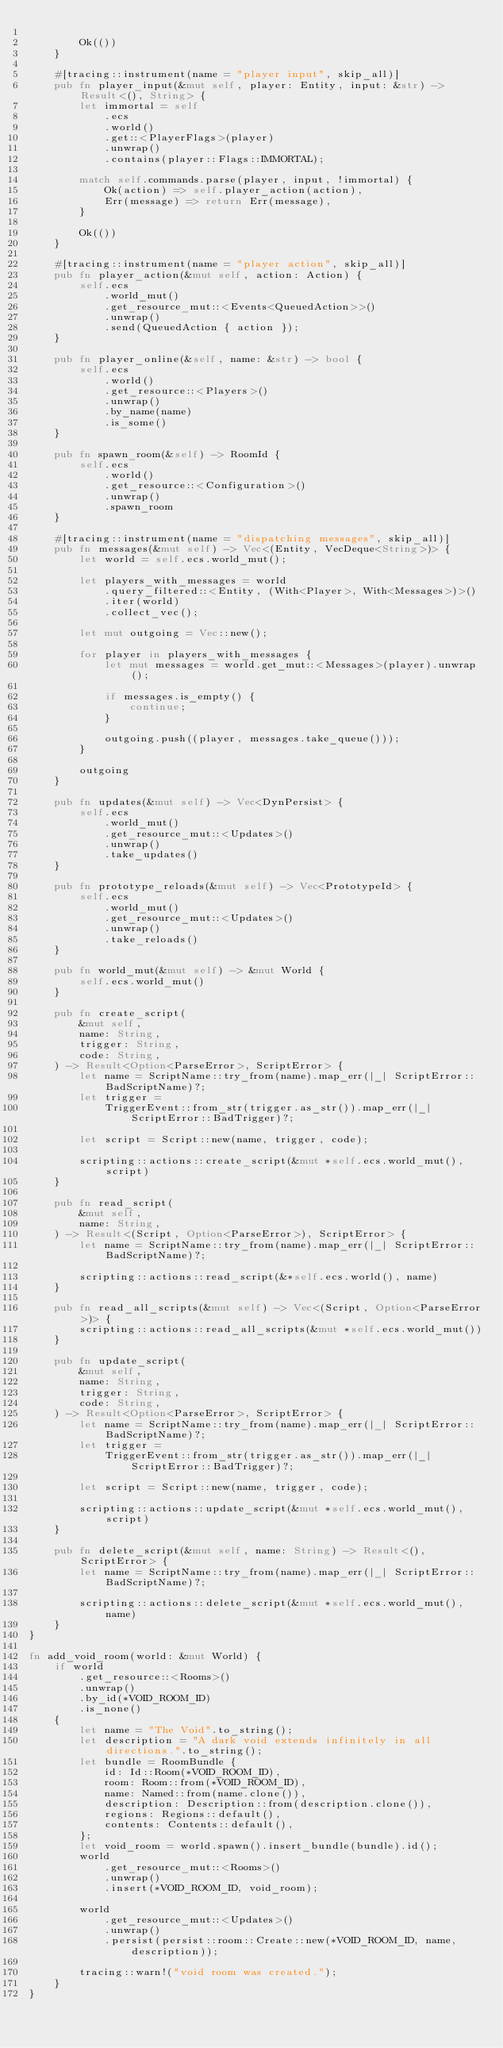<code> <loc_0><loc_0><loc_500><loc_500><_Rust_>
        Ok(())
    }

    #[tracing::instrument(name = "player input", skip_all)]
    pub fn player_input(&mut self, player: Entity, input: &str) -> Result<(), String> {
        let immortal = self
            .ecs
            .world()
            .get::<PlayerFlags>(player)
            .unwrap()
            .contains(player::Flags::IMMORTAL);

        match self.commands.parse(player, input, !immortal) {
            Ok(action) => self.player_action(action),
            Err(message) => return Err(message),
        }

        Ok(())
    }

    #[tracing::instrument(name = "player action", skip_all)]
    pub fn player_action(&mut self, action: Action) {
        self.ecs
            .world_mut()
            .get_resource_mut::<Events<QueuedAction>>()
            .unwrap()
            .send(QueuedAction { action });
    }

    pub fn player_online(&self, name: &str) -> bool {
        self.ecs
            .world()
            .get_resource::<Players>()
            .unwrap()
            .by_name(name)
            .is_some()
    }

    pub fn spawn_room(&self) -> RoomId {
        self.ecs
            .world()
            .get_resource::<Configuration>()
            .unwrap()
            .spawn_room
    }

    #[tracing::instrument(name = "dispatching messages", skip_all)]
    pub fn messages(&mut self) -> Vec<(Entity, VecDeque<String>)> {
        let world = self.ecs.world_mut();

        let players_with_messages = world
            .query_filtered::<Entity, (With<Player>, With<Messages>)>()
            .iter(world)
            .collect_vec();

        let mut outgoing = Vec::new();

        for player in players_with_messages {
            let mut messages = world.get_mut::<Messages>(player).unwrap();

            if messages.is_empty() {
                continue;
            }

            outgoing.push((player, messages.take_queue()));
        }

        outgoing
    }

    pub fn updates(&mut self) -> Vec<DynPersist> {
        self.ecs
            .world_mut()
            .get_resource_mut::<Updates>()
            .unwrap()
            .take_updates()
    }

    pub fn prototype_reloads(&mut self) -> Vec<PrototypeId> {
        self.ecs
            .world_mut()
            .get_resource_mut::<Updates>()
            .unwrap()
            .take_reloads()
    }

    pub fn world_mut(&mut self) -> &mut World {
        self.ecs.world_mut()
    }

    pub fn create_script(
        &mut self,
        name: String,
        trigger: String,
        code: String,
    ) -> Result<Option<ParseError>, ScriptError> {
        let name = ScriptName::try_from(name).map_err(|_| ScriptError::BadScriptName)?;
        let trigger =
            TriggerEvent::from_str(trigger.as_str()).map_err(|_| ScriptError::BadTrigger)?;

        let script = Script::new(name, trigger, code);

        scripting::actions::create_script(&mut *self.ecs.world_mut(), script)
    }

    pub fn read_script(
        &mut self,
        name: String,
    ) -> Result<(Script, Option<ParseError>), ScriptError> {
        let name = ScriptName::try_from(name).map_err(|_| ScriptError::BadScriptName)?;

        scripting::actions::read_script(&*self.ecs.world(), name)
    }

    pub fn read_all_scripts(&mut self) -> Vec<(Script, Option<ParseError>)> {
        scripting::actions::read_all_scripts(&mut *self.ecs.world_mut())
    }

    pub fn update_script(
        &mut self,
        name: String,
        trigger: String,
        code: String,
    ) -> Result<Option<ParseError>, ScriptError> {
        let name = ScriptName::try_from(name).map_err(|_| ScriptError::BadScriptName)?;
        let trigger =
            TriggerEvent::from_str(trigger.as_str()).map_err(|_| ScriptError::BadTrigger)?;

        let script = Script::new(name, trigger, code);

        scripting::actions::update_script(&mut *self.ecs.world_mut(), script)
    }

    pub fn delete_script(&mut self, name: String) -> Result<(), ScriptError> {
        let name = ScriptName::try_from(name).map_err(|_| ScriptError::BadScriptName)?;

        scripting::actions::delete_script(&mut *self.ecs.world_mut(), name)
    }
}

fn add_void_room(world: &mut World) {
    if world
        .get_resource::<Rooms>()
        .unwrap()
        .by_id(*VOID_ROOM_ID)
        .is_none()
    {
        let name = "The Void".to_string();
        let description = "A dark void extends infinitely in all directions.".to_string();
        let bundle = RoomBundle {
            id: Id::Room(*VOID_ROOM_ID),
            room: Room::from(*VOID_ROOM_ID),
            name: Named::from(name.clone()),
            description: Description::from(description.clone()),
            regions: Regions::default(),
            contents: Contents::default(),
        };
        let void_room = world.spawn().insert_bundle(bundle).id();
        world
            .get_resource_mut::<Rooms>()
            .unwrap()
            .insert(*VOID_ROOM_ID, void_room);

        world
            .get_resource_mut::<Updates>()
            .unwrap()
            .persist(persist::room::Create::new(*VOID_ROOM_ID, name, description));

        tracing::warn!("void room was created.");
    }
}
</code> 